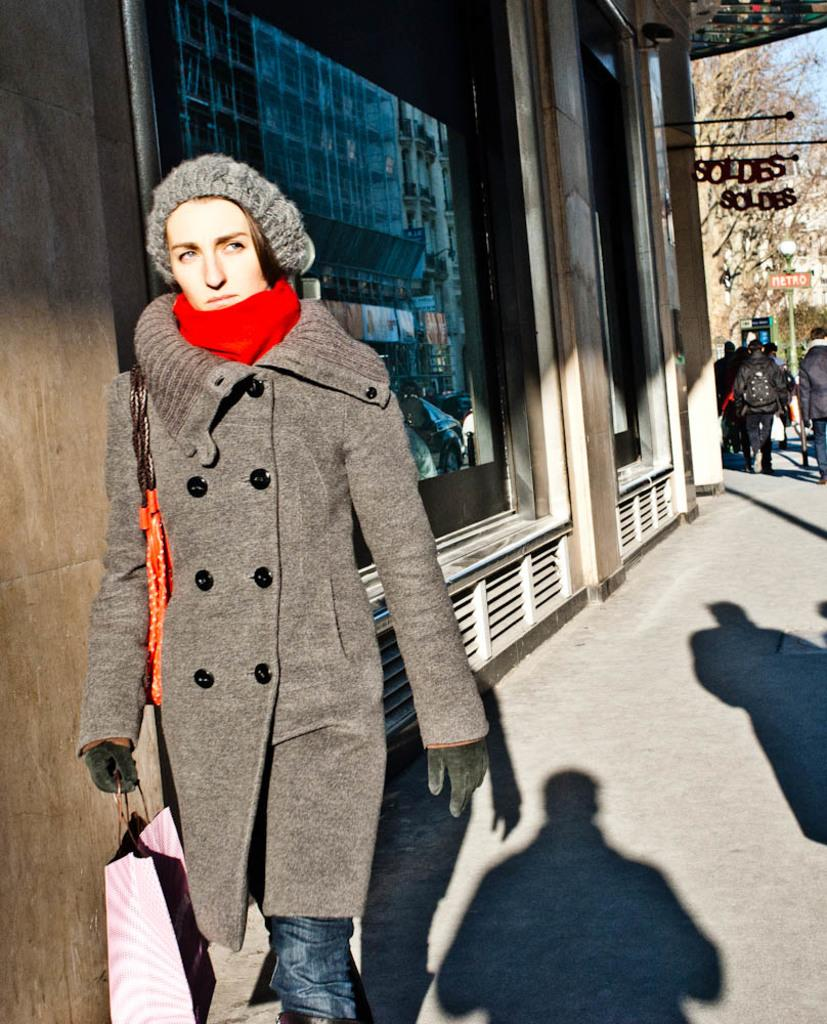Who is the main subject in the foreground of the image? There is a woman in the foreground of the image. What is the woman holding in the image? The woman is holding a bag. Can you describe the people on the right side of the image? There are people standing on the right side of the image. What type of drink is the actor holding in the image? There is no actor or drink present in the image. How many ducks can be seen swimming in the background of the image? There are no ducks present in the image. 